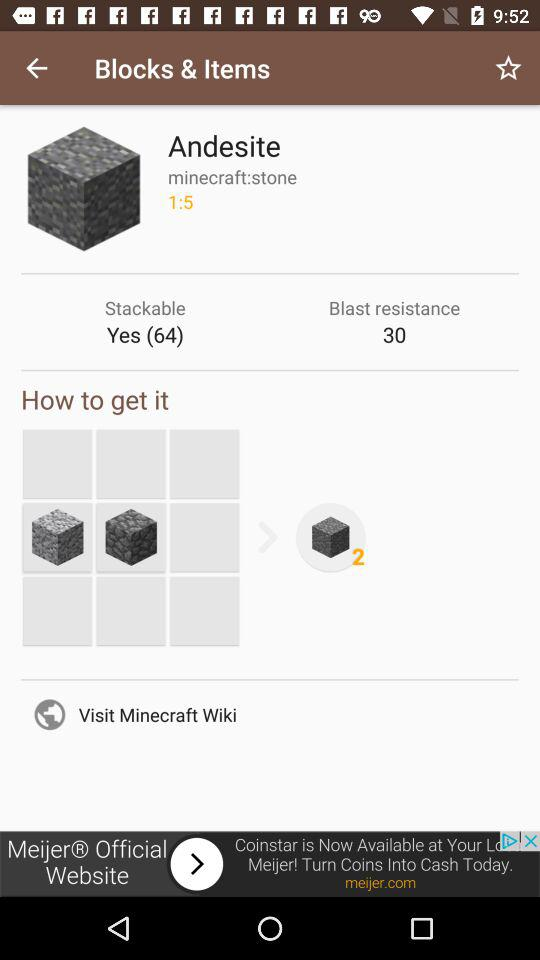What is the blast resistance of the andesite block?
Answer the question using a single word or phrase. 30 